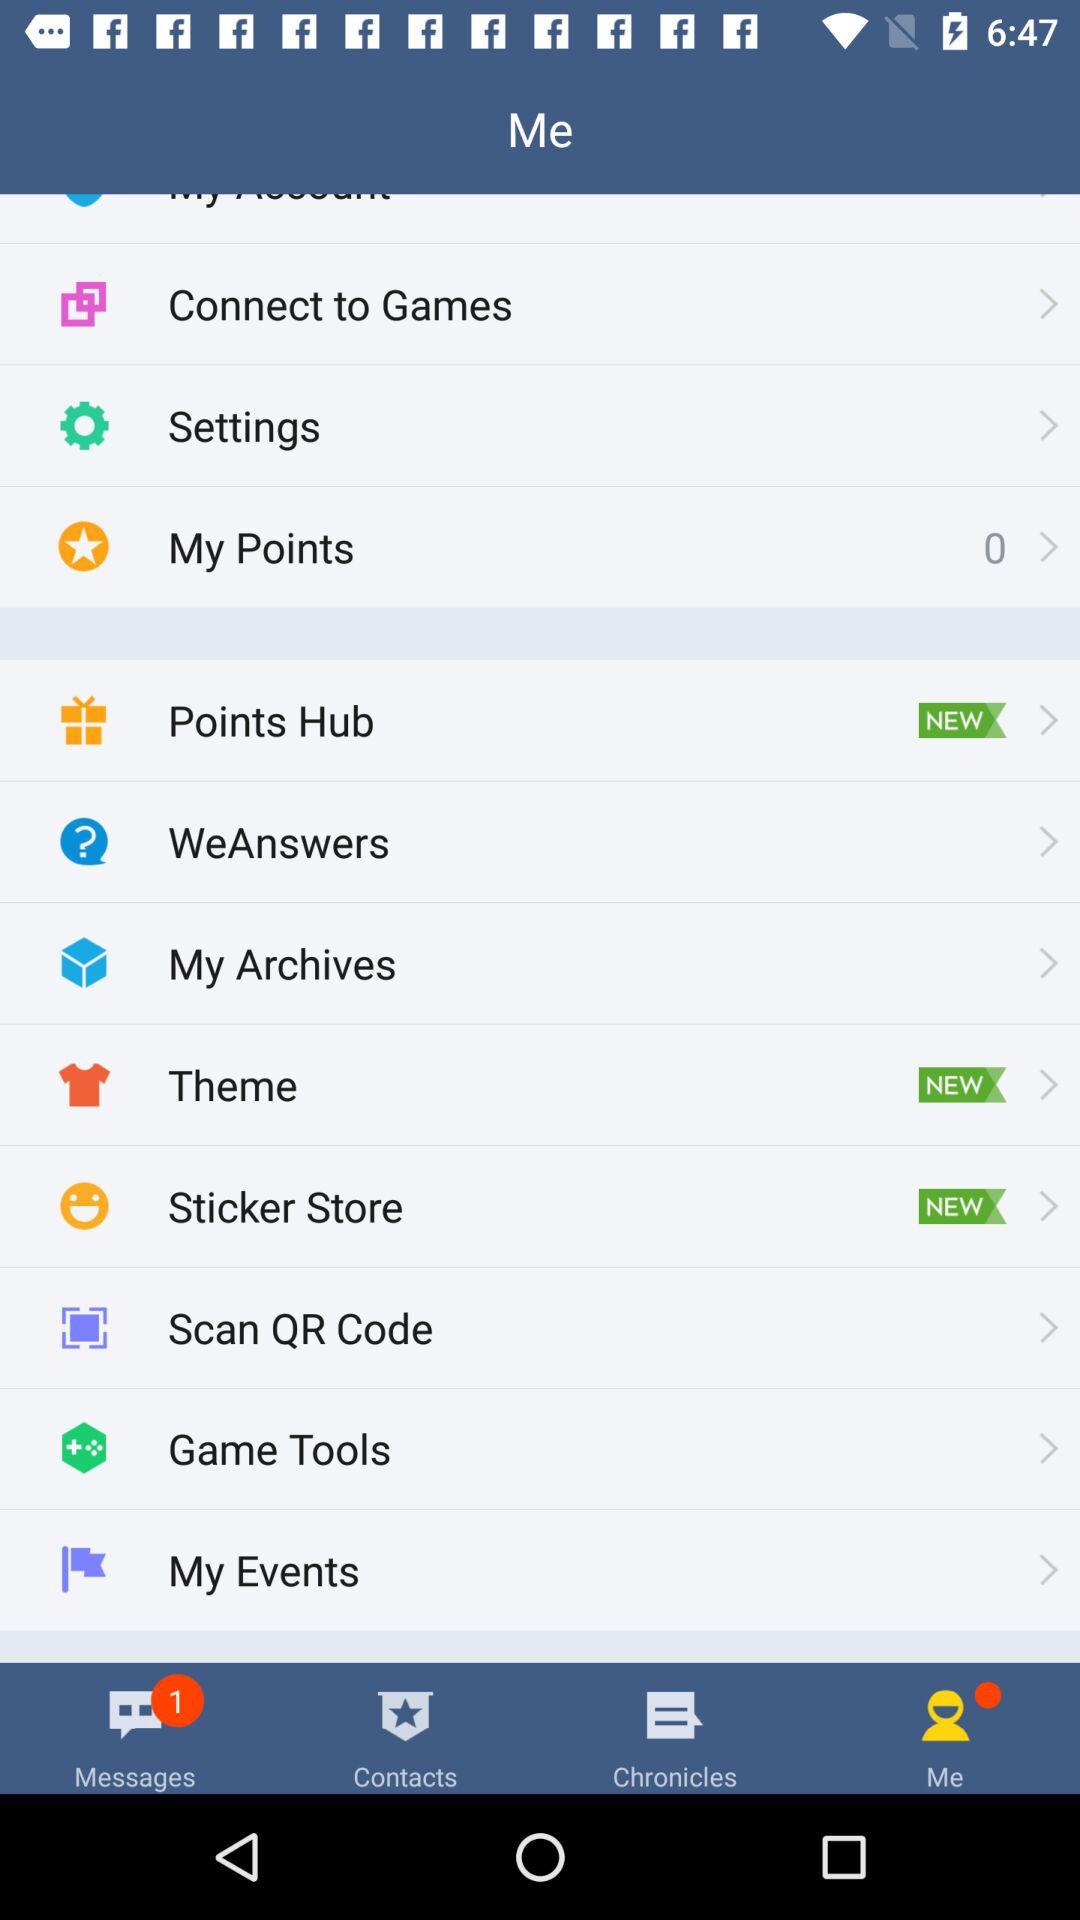What is the count of my points? The count is 0. 